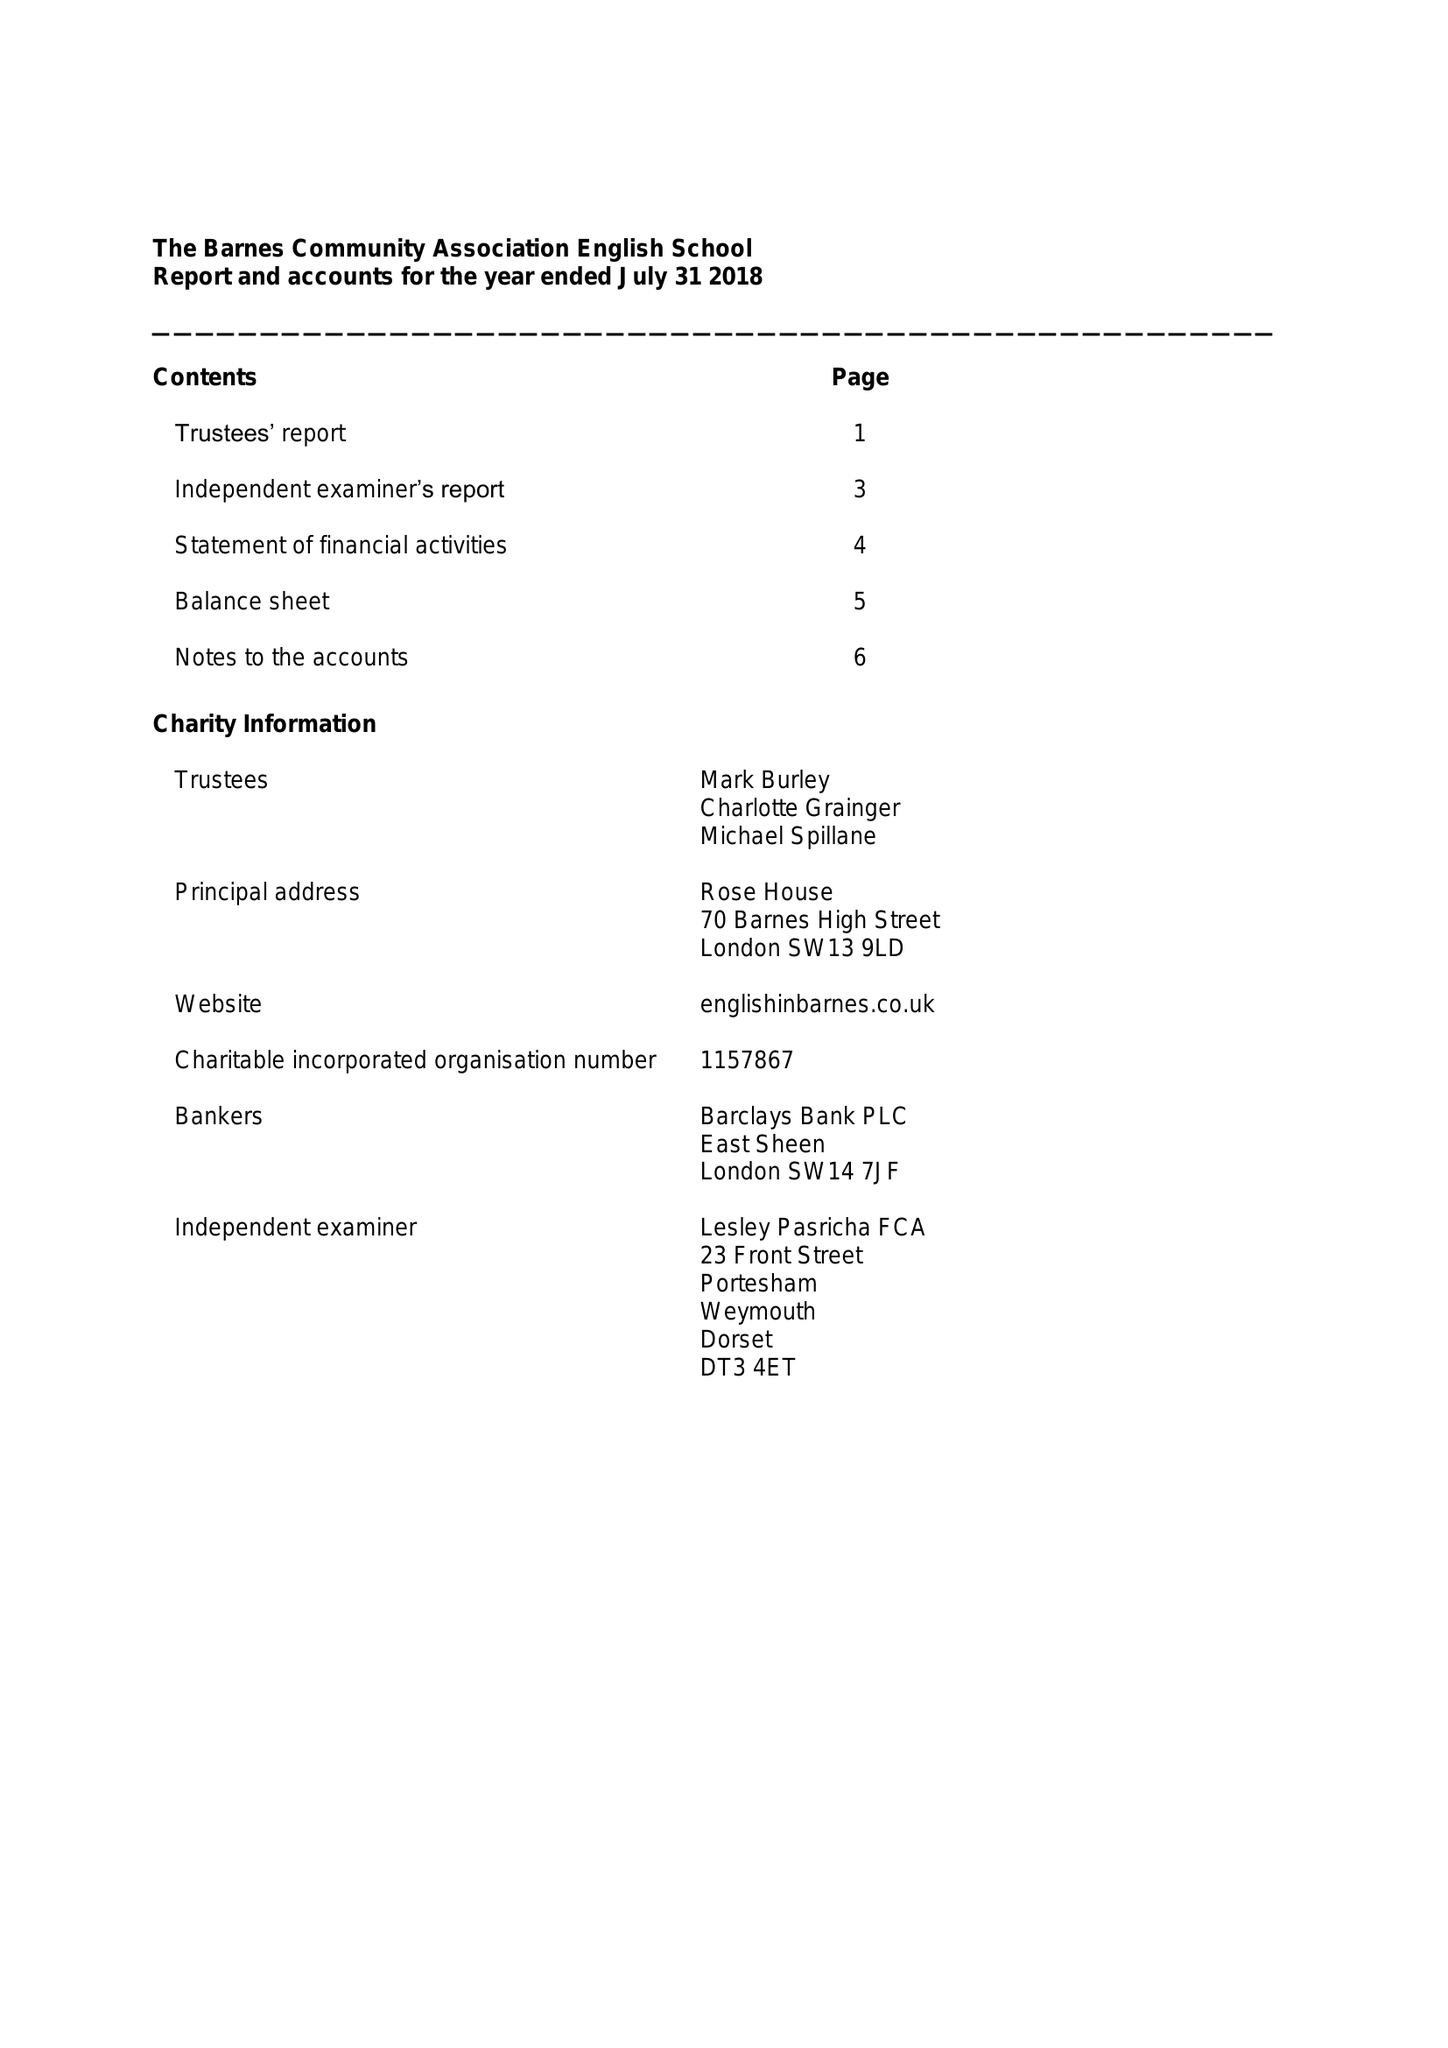What is the value for the spending_annually_in_british_pounds?
Answer the question using a single word or phrase. 141188.00 